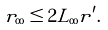<formula> <loc_0><loc_0><loc_500><loc_500>r _ { \infty } \leq 2 L _ { \infty } r ^ { \prime } .</formula> 